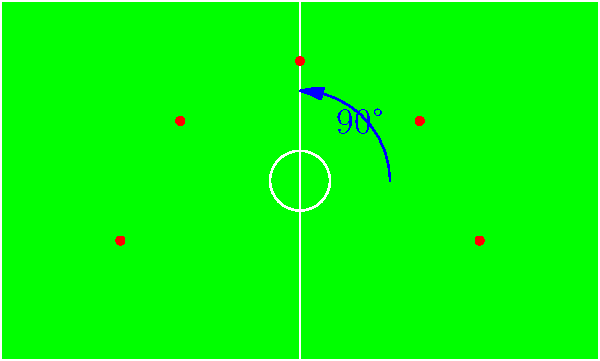In a 5-player defensive formation, if the pitch is rotated 90° clockwise, which of the following positions will the central defender (initially at (0,2)) occupy?
A) (-2,0)
B) (2,0)
C) (0,-2)
D) (3,-1) To solve this problem, we need to follow these steps:

1. Identify the initial position of the central defender: (0,2)

2. Understand the rotation:
   - 90° clockwise rotation means we're rotating the entire pitch and formation
   - This rotation transforms (x,y) coordinates to (y,-x)

3. Apply the rotation to the central defender's coordinates:
   - Initial coordinates: (0,2)
   - After rotation: (2,0)

4. Check the given options and select the matching coordinates

The rotation transforms the central defender's position from (0,2) to (2,0), which corresponds to option B.

This mental rotation exercise is crucial for defensive tactics, allowing quick adaptation to different field orientations and opponent formations.
Answer: B) (2,0) 